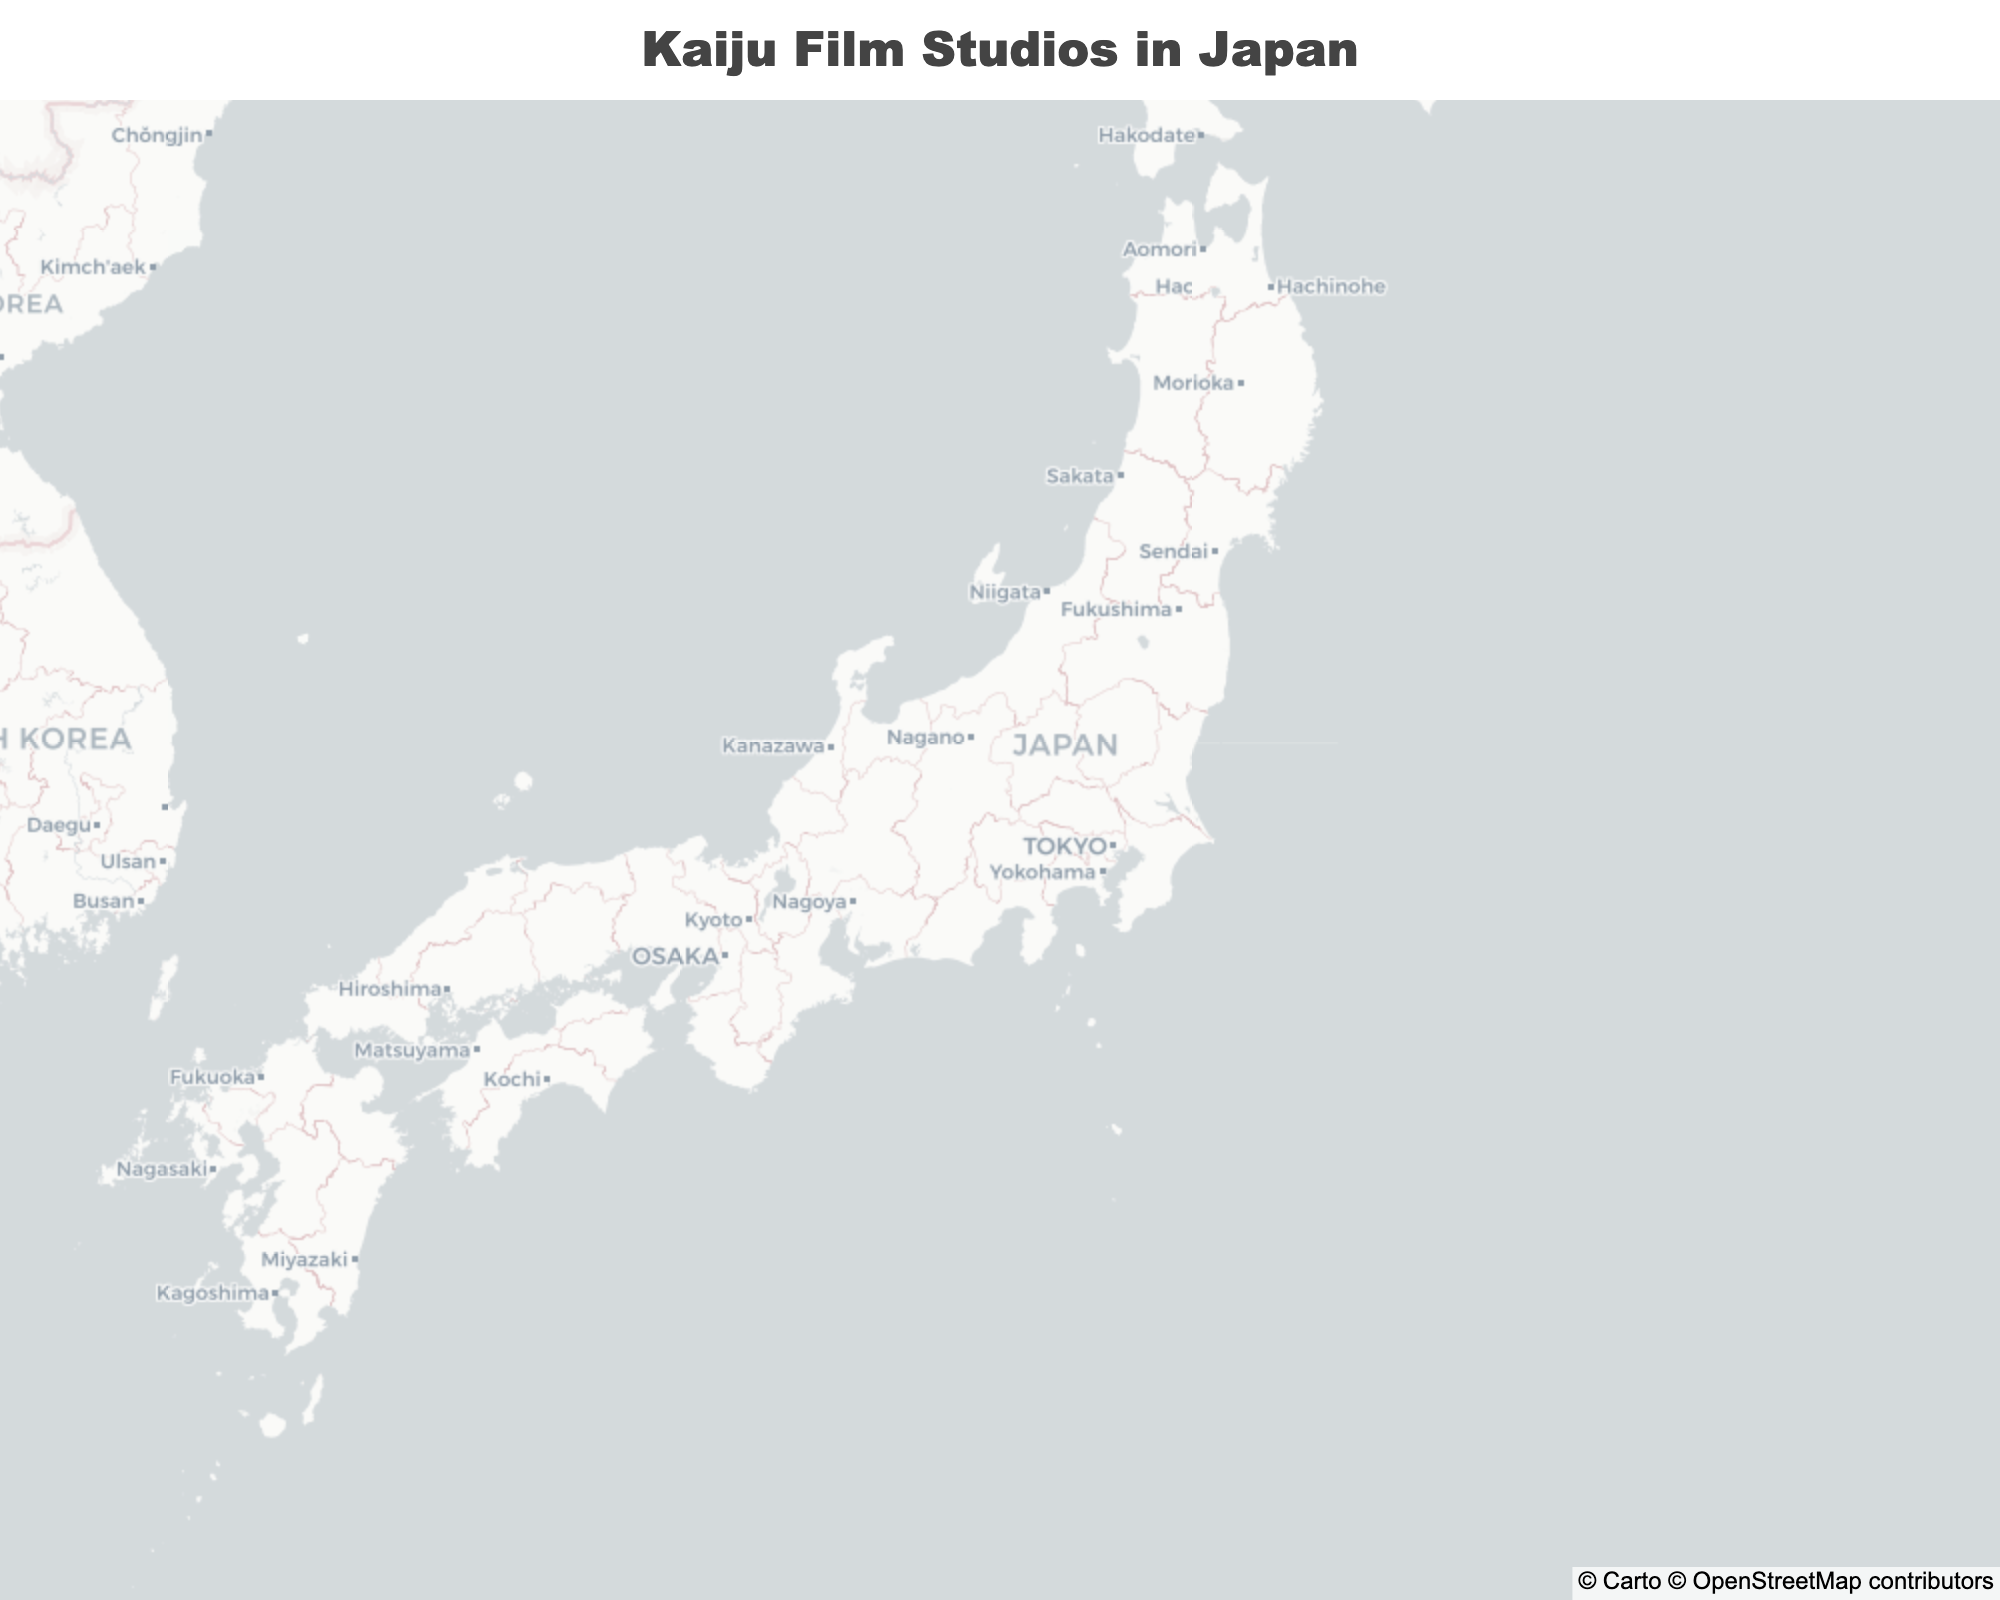How many studios are located in Tokyo? By visually inspecting the map, we can count the marker points located in Tokyo. There are markers labeled Toho Studios, Nikkatsu Chofu Studio, Kadokawa Daiei Studio, Toei Tokyo Studio, Sunrise Studios, and Studio Ghibli in Tokyo.
Answer: 6 What is the northernmost studio on the map? The northernmost studio is the one with the highest latitude value. Tsuburaya Productions in Sukagawa has the highest latitude of 37.2861.
Answer: Tsuburaya Productions Which city has the most kaiju film studios, Kyoto or Tokyo? By counting the number of markers in each city, Kyoto has Shochiku Kyoto Studio, Eizo Kyoto Studio, and Toei Kyoto Studio (3). Tokyo has Toho Studios, Nikkatsu Chofu Studio, Kadokawa Daiei Studio, Toei Tokyo Studio, Sunrise Studios, and Studio Ghibli (6).
Answer: Tokyo What is the average latitude of Toei Kyoto Studio and Toei Tokyo Studio? To find the average latitude of these two points, sum their latitudes (35.0139 for Toei Kyoto Studio and 35.7189 for Toei Tokyo Studio) and divide by 2.  (35.0139 + 35.7189) / 2 = 35.3664.
Answer: 35.3664 Which studio is closest to 35.0116 latitude and 135.7681 longitude? Shochiku Kyoto Studio is at the coordinates 35.0116 latitude and 135.7681 longitude, matching the given coordinates exactly.
Answer: Shochiku Kyoto Studio What is the latitude and longitude of the southernmost studio in Kyoto? The southernmost studio in Kyoto is the one with the lowest latitude value. Eizo Kyoto Studio has the lowest latitude of 34.9858 and longitude of 135.7588.
Answer: 34.9858, 135.7588 If you wanted to visit every studio in Tokyo, approximately how many unique locations would you visit? By counting the unique studio locations in Tokyo, there are six studios (Toho Studios, Nikkatsu Chofu Studio, Kadokawa Daiei Studio, Toei Tokyo Studio, Sunrise Studios, and Studio Ghibli). However, since some share close or identical coordinates, the unique studio count remains at six.
Answer: 6 Compare the easternmost studio in Tokyo to the westernmost. Which studio comes farther east? The easternmost studio has the highest longitude value. Toho Studios is the easternmost at 139.6503, while Nikkatsu Chofu Studio is the westernmost in Tokyo at 139.5408.
Answer: Toho Studios Are there any studios located very close (within 0.005 degrees) to each other? By examining the coordinates, we find that Toei Tokyo Studio (35.7189, 139.6917) and Kadokawa Daiei Studio (35.7147, 139.5713) are not within 0.005 degrees proximity but are relatively close. Similarly, Studio Ghibli (35.6964, 139.5703) and Sunrise Studios (35.7022, 139.5797) are also close.
Answer: No How far is the latitude difference between the northernmost and southernmost studios in Kyoto? Tsuburaya Productions in Sukagawa is at 37.2861 latitude while Eizo Kyoto Studio in Kyoto is at 34.9858 latitude. The difference is 37.2861 - 34.9858 = 2.3003 degrees.
Answer: 2.3003 degrees 